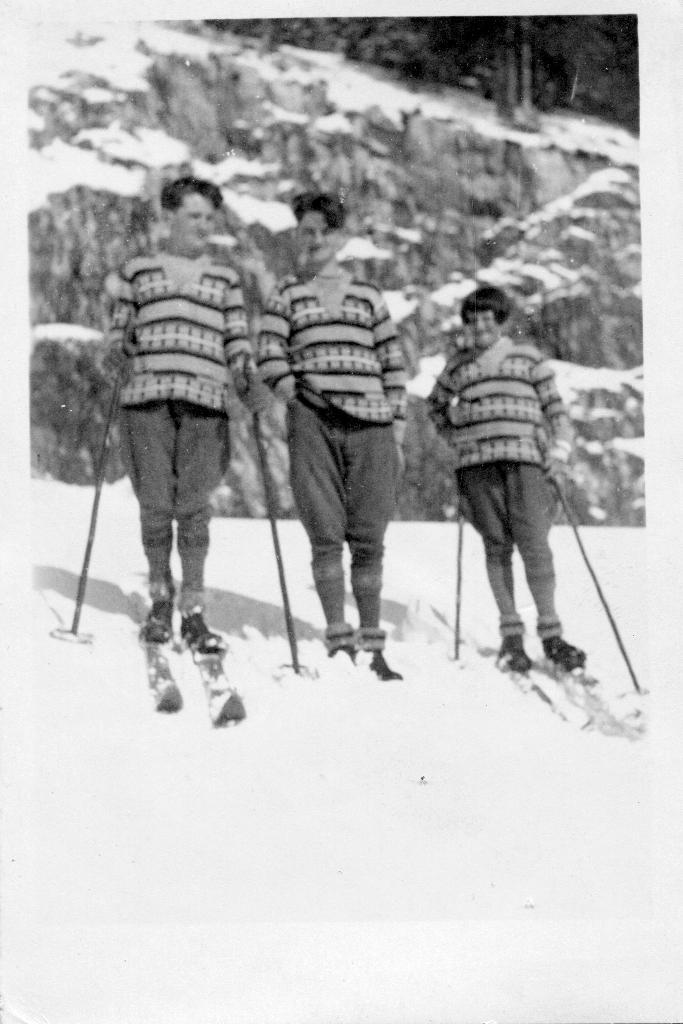What is the color scheme of the image? The image is black and white. How many people are in the image? There are three persons in the image. What is the surface they are standing on? The persons are standing on snow. What equipment do the persons have for skiing? The persons have ski boards and are holding ski poles. Can you describe the background of the image? The background of the image is blurred. What type of band can be heard playing in the background of the image? There is no band present in the image, as it is a black and white photograph of three people skiing on snow. What is the zephyr's role in the image? There is no zephyr mentioned or depicted in the image; it is a photograph of people skiing on snow. 